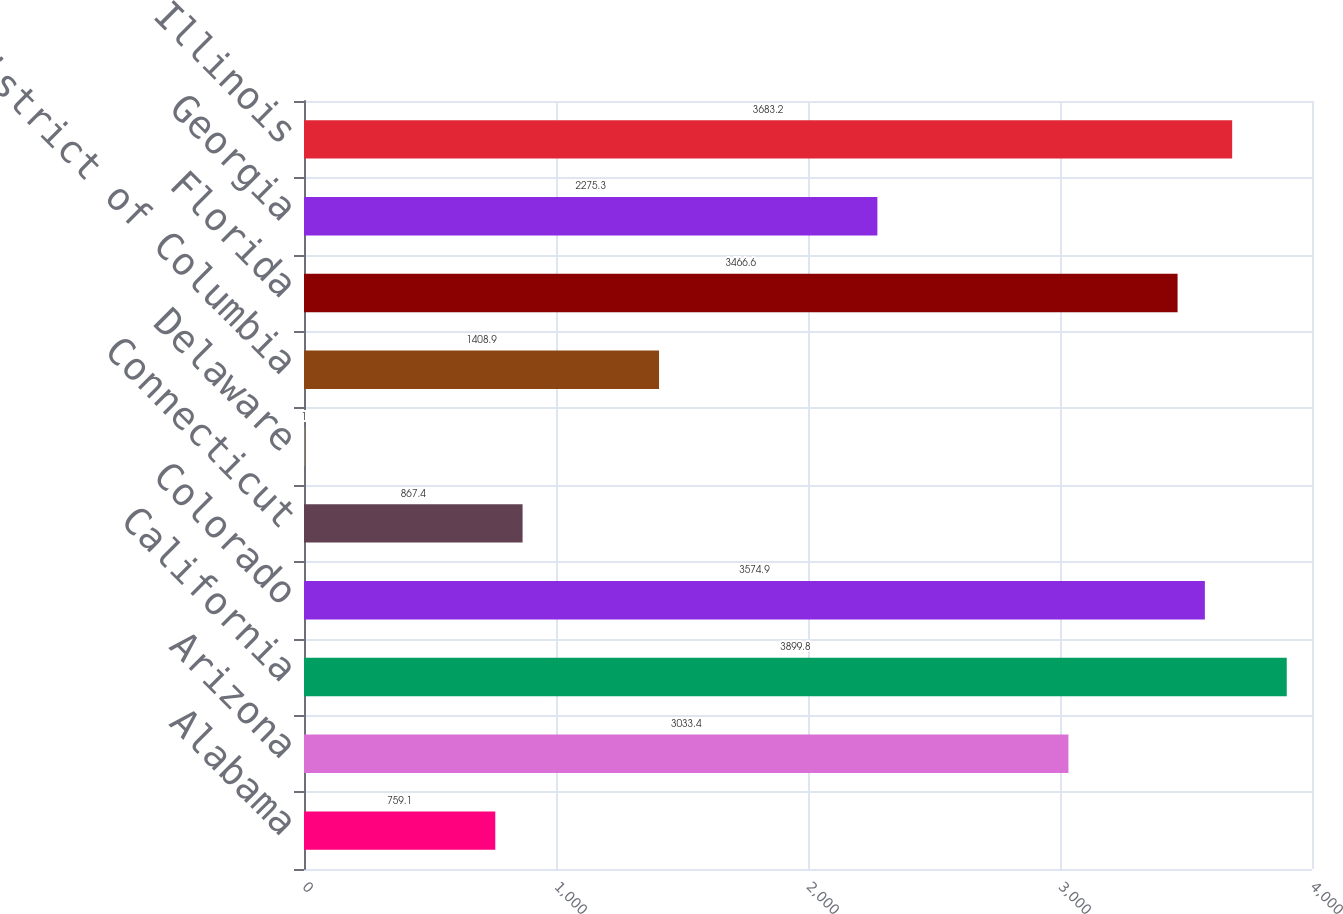<chart> <loc_0><loc_0><loc_500><loc_500><bar_chart><fcel>Alabama<fcel>Arizona<fcel>California<fcel>Colorado<fcel>Connecticut<fcel>Delaware<fcel>District of Columbia<fcel>Florida<fcel>Georgia<fcel>Illinois<nl><fcel>759.1<fcel>3033.4<fcel>3899.8<fcel>3574.9<fcel>867.4<fcel>1<fcel>1408.9<fcel>3466.6<fcel>2275.3<fcel>3683.2<nl></chart> 